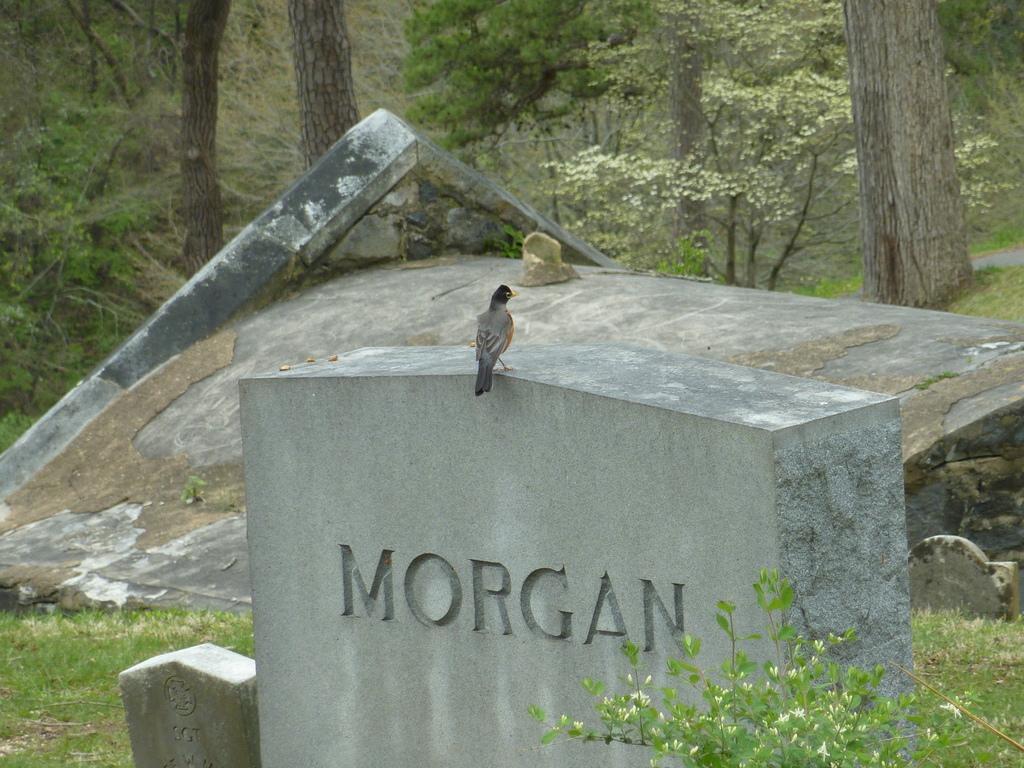How would you summarize this image in a sentence or two? In the picture we can see bird which is on the surface of a stone wall and in the background of the picture there are some trees. 